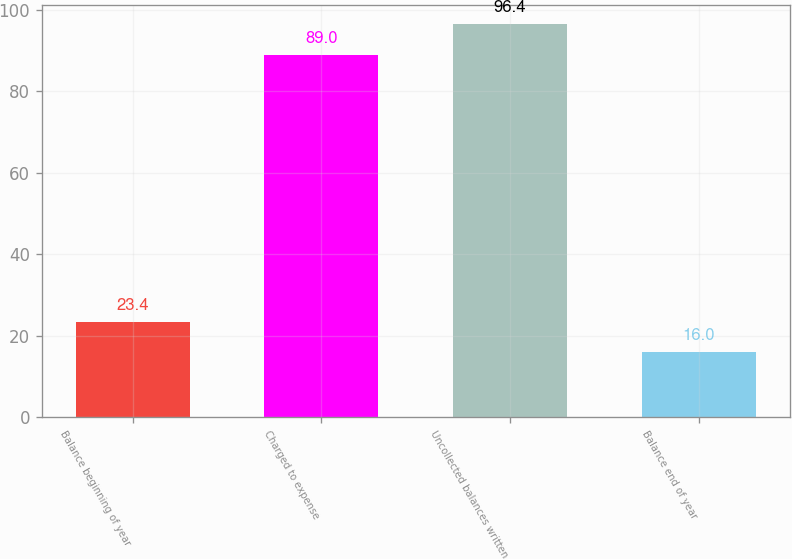<chart> <loc_0><loc_0><loc_500><loc_500><bar_chart><fcel>Balance beginning of year<fcel>Charged to expense<fcel>Uncollected balances written<fcel>Balance end of year<nl><fcel>23.4<fcel>89<fcel>96.4<fcel>16<nl></chart> 